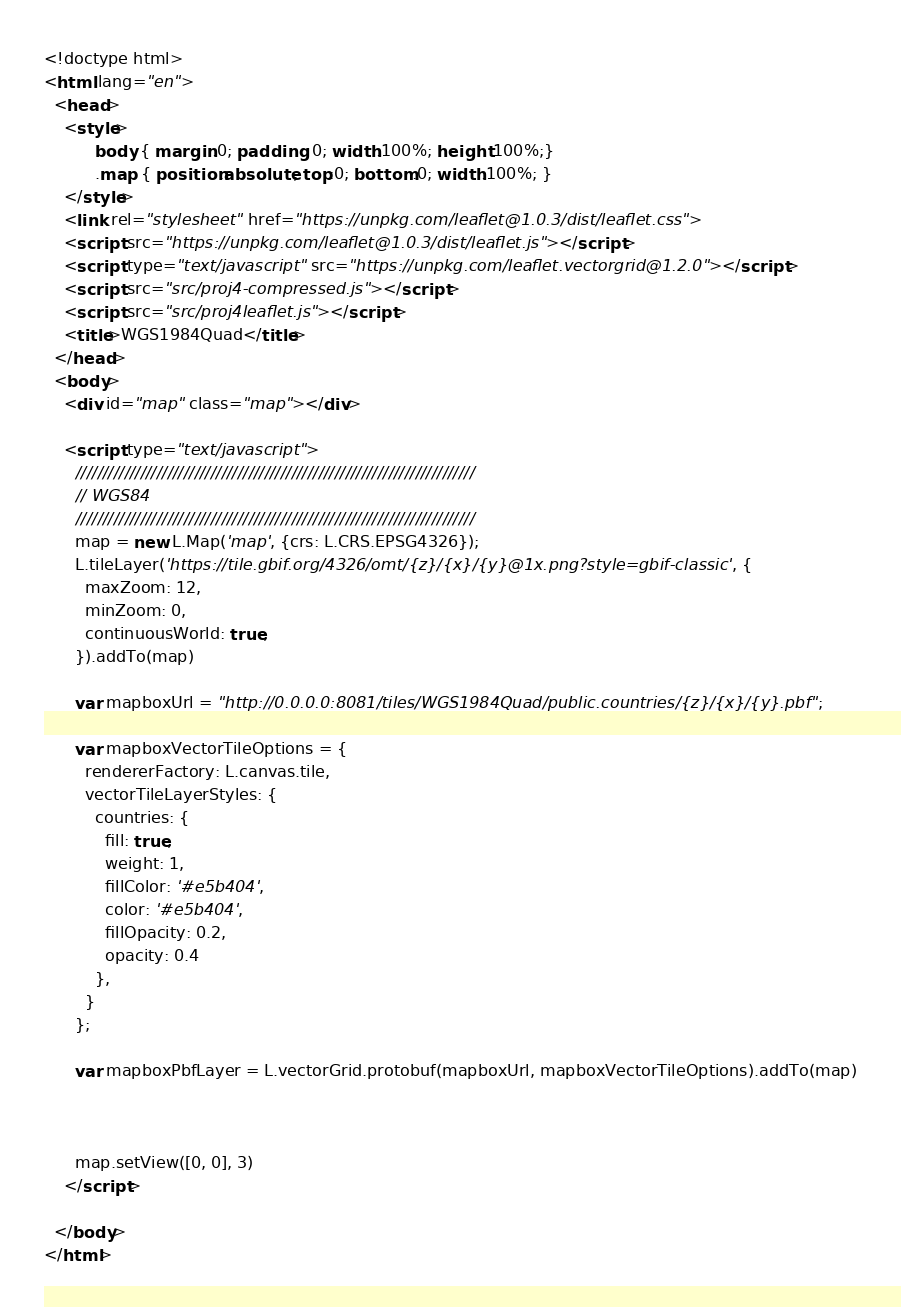<code> <loc_0><loc_0><loc_500><loc_500><_HTML_><!doctype html>
<html lang="en">
  <head>
    <style>
		  body { margin:0; padding: 0; width:100%; height:100%;}
		  .map { position:absolute; top:0; bottom:0; width:100%; }
    </style>
    <link rel="stylesheet" href="https://unpkg.com/leaflet@1.0.3/dist/leaflet.css">
    <script src="https://unpkg.com/leaflet@1.0.3/dist/leaflet.js"></script>
    <script type="text/javascript" src="https://unpkg.com/leaflet.vectorgrid@1.2.0"></script>
    <script src="src/proj4-compressed.js"></script>
    <script src="src/proj4leaflet.js"></script>
    <title>WGS1984Quad</title>
  </head>
  <body>
    <div id="map" class="map"></div>

	<script type="text/javascript">
      //////////////////////////////////////////////////////////////////////////
      // WGS84
      //////////////////////////////////////////////////////////////////////////
      map = new L.Map('map', {crs: L.CRS.EPSG4326});
      L.tileLayer('https://tile.gbif.org/4326/omt/{z}/{x}/{y}@1x.png?style=gbif-classic', {
        maxZoom: 12,
        minZoom: 0,
        continuousWorld: true,
      }).addTo(map)

      var mapboxUrl = "http://0.0.0.0:8081/tiles/WGS1984Quad/public.countries/{z}/{x}/{y}.pbf";

      var mapboxVectorTileOptions = {
        rendererFactory: L.canvas.tile,
        vectorTileLayerStyles: {
          countries: {
            fill: true,
            weight: 1,
            fillColor: '#e5b404',
            color: '#e5b404',
            fillOpacity: 0.2,
            opacity: 0.4
          },
        }
      };

      var mapboxPbfLayer = L.vectorGrid.protobuf(mapboxUrl, mapboxVectorTileOptions).addTo(map)



      map.setView([0, 0], 3)
    </script>

  </body>
</html>
</code> 